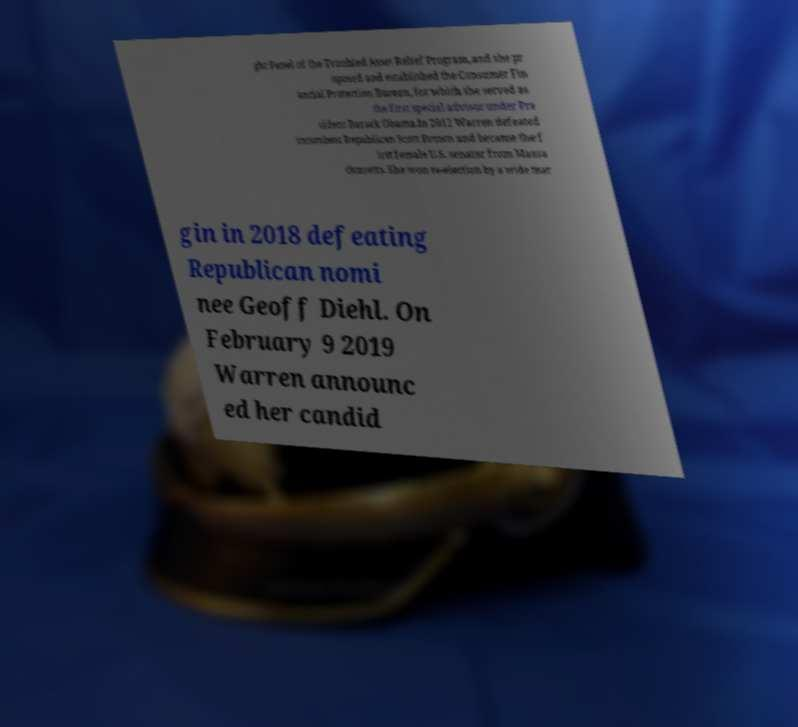Could you extract and type out the text from this image? ght Panel of the Troubled Asset Relief Program, and she pr oposed and established the Consumer Fin ancial Protection Bureau, for which she served as the first special advisor under Pre sident Barack Obama.In 2012 Warren defeated incumbent Republican Scott Brown and became the f irst female U.S. senator from Massa chusetts. She won re-election by a wide mar gin in 2018 defeating Republican nomi nee Geoff Diehl. On February 9 2019 Warren announc ed her candid 